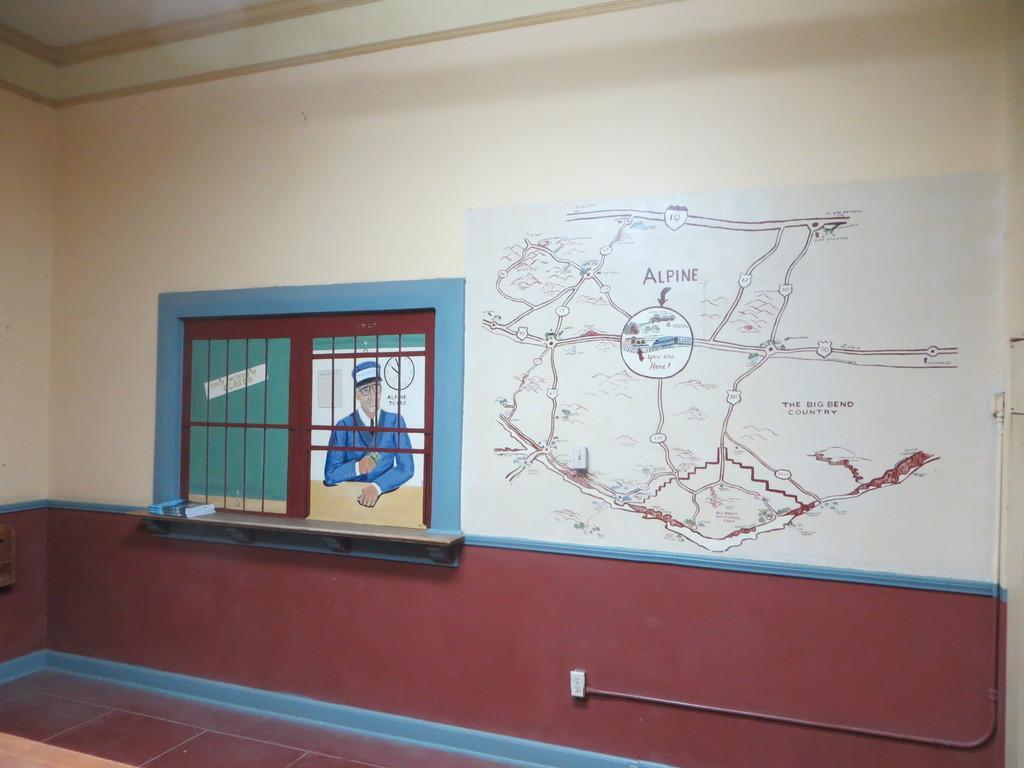How would you summarize this image in a sentence or two? In the foreground of this image, there is a wall. On the wall, there is a painting and a map. On the top, there is the ceiling. 